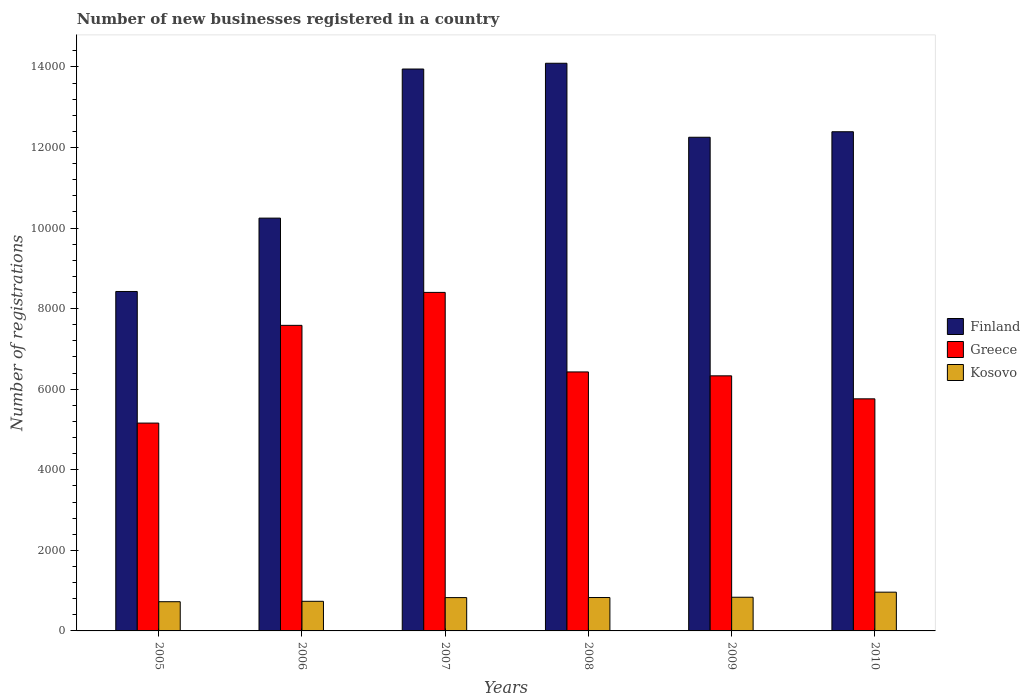How many different coloured bars are there?
Offer a very short reply. 3. How many groups of bars are there?
Ensure brevity in your answer.  6. Are the number of bars per tick equal to the number of legend labels?
Provide a succinct answer. Yes. Are the number of bars on each tick of the X-axis equal?
Offer a very short reply. Yes. How many bars are there on the 5th tick from the right?
Your answer should be very brief. 3. What is the number of new businesses registered in Greece in 2006?
Make the answer very short. 7585. Across all years, what is the maximum number of new businesses registered in Finland?
Your answer should be very brief. 1.41e+04. Across all years, what is the minimum number of new businesses registered in Kosovo?
Offer a terse response. 725. In which year was the number of new businesses registered in Kosovo maximum?
Offer a terse response. 2010. In which year was the number of new businesses registered in Kosovo minimum?
Make the answer very short. 2005. What is the total number of new businesses registered in Greece in the graph?
Make the answer very short. 3.97e+04. What is the difference between the number of new businesses registered in Finland in 2005 and that in 2009?
Your answer should be very brief. -3828. What is the difference between the number of new businesses registered in Greece in 2010 and the number of new businesses registered in Kosovo in 2009?
Provide a succinct answer. 4925. What is the average number of new businesses registered in Kosovo per year?
Make the answer very short. 819. In the year 2006, what is the difference between the number of new businesses registered in Greece and number of new businesses registered in Finland?
Your answer should be compact. -2662. What is the ratio of the number of new businesses registered in Greece in 2005 to that in 2009?
Offer a terse response. 0.81. Is the number of new businesses registered in Kosovo in 2005 less than that in 2009?
Make the answer very short. Yes. Is the difference between the number of new businesses registered in Greece in 2006 and 2010 greater than the difference between the number of new businesses registered in Finland in 2006 and 2010?
Offer a very short reply. Yes. What is the difference between the highest and the second highest number of new businesses registered in Finland?
Offer a very short reply. 143. What is the difference between the highest and the lowest number of new businesses registered in Kosovo?
Keep it short and to the point. 237. Is the sum of the number of new businesses registered in Finland in 2006 and 2008 greater than the maximum number of new businesses registered in Greece across all years?
Give a very brief answer. Yes. What does the 2nd bar from the left in 2006 represents?
Make the answer very short. Greece. How many bars are there?
Your response must be concise. 18. Are the values on the major ticks of Y-axis written in scientific E-notation?
Keep it short and to the point. No. Does the graph contain any zero values?
Offer a very short reply. No. Where does the legend appear in the graph?
Ensure brevity in your answer.  Center right. How many legend labels are there?
Offer a terse response. 3. How are the legend labels stacked?
Ensure brevity in your answer.  Vertical. What is the title of the graph?
Offer a very short reply. Number of new businesses registered in a country. What is the label or title of the X-axis?
Your response must be concise. Years. What is the label or title of the Y-axis?
Offer a terse response. Number of registrations. What is the Number of registrations of Finland in 2005?
Offer a terse response. 8426. What is the Number of registrations of Greece in 2005?
Give a very brief answer. 5159. What is the Number of registrations of Kosovo in 2005?
Keep it short and to the point. 725. What is the Number of registrations of Finland in 2006?
Keep it short and to the point. 1.02e+04. What is the Number of registrations of Greece in 2006?
Your answer should be very brief. 7585. What is the Number of registrations of Kosovo in 2006?
Offer a very short reply. 735. What is the Number of registrations in Finland in 2007?
Ensure brevity in your answer.  1.39e+04. What is the Number of registrations of Greece in 2007?
Provide a short and direct response. 8403. What is the Number of registrations in Kosovo in 2007?
Provide a short and direct response. 827. What is the Number of registrations of Finland in 2008?
Make the answer very short. 1.41e+04. What is the Number of registrations in Greece in 2008?
Your response must be concise. 6429. What is the Number of registrations in Kosovo in 2008?
Ensure brevity in your answer.  829. What is the Number of registrations in Finland in 2009?
Offer a terse response. 1.23e+04. What is the Number of registrations of Greece in 2009?
Offer a very short reply. 6332. What is the Number of registrations in Kosovo in 2009?
Make the answer very short. 836. What is the Number of registrations in Finland in 2010?
Make the answer very short. 1.24e+04. What is the Number of registrations of Greece in 2010?
Make the answer very short. 5761. What is the Number of registrations of Kosovo in 2010?
Offer a terse response. 962. Across all years, what is the maximum Number of registrations of Finland?
Offer a terse response. 1.41e+04. Across all years, what is the maximum Number of registrations in Greece?
Offer a very short reply. 8403. Across all years, what is the maximum Number of registrations in Kosovo?
Offer a very short reply. 962. Across all years, what is the minimum Number of registrations of Finland?
Give a very brief answer. 8426. Across all years, what is the minimum Number of registrations in Greece?
Provide a succinct answer. 5159. Across all years, what is the minimum Number of registrations of Kosovo?
Provide a short and direct response. 725. What is the total Number of registrations in Finland in the graph?
Make the answer very short. 7.14e+04. What is the total Number of registrations in Greece in the graph?
Keep it short and to the point. 3.97e+04. What is the total Number of registrations in Kosovo in the graph?
Your answer should be very brief. 4914. What is the difference between the Number of registrations in Finland in 2005 and that in 2006?
Your answer should be very brief. -1821. What is the difference between the Number of registrations in Greece in 2005 and that in 2006?
Your response must be concise. -2426. What is the difference between the Number of registrations of Finland in 2005 and that in 2007?
Keep it short and to the point. -5522. What is the difference between the Number of registrations in Greece in 2005 and that in 2007?
Your response must be concise. -3244. What is the difference between the Number of registrations in Kosovo in 2005 and that in 2007?
Offer a terse response. -102. What is the difference between the Number of registrations in Finland in 2005 and that in 2008?
Ensure brevity in your answer.  -5665. What is the difference between the Number of registrations of Greece in 2005 and that in 2008?
Your answer should be compact. -1270. What is the difference between the Number of registrations of Kosovo in 2005 and that in 2008?
Ensure brevity in your answer.  -104. What is the difference between the Number of registrations in Finland in 2005 and that in 2009?
Keep it short and to the point. -3828. What is the difference between the Number of registrations of Greece in 2005 and that in 2009?
Keep it short and to the point. -1173. What is the difference between the Number of registrations in Kosovo in 2005 and that in 2009?
Ensure brevity in your answer.  -111. What is the difference between the Number of registrations of Finland in 2005 and that in 2010?
Make the answer very short. -3965. What is the difference between the Number of registrations in Greece in 2005 and that in 2010?
Keep it short and to the point. -602. What is the difference between the Number of registrations of Kosovo in 2005 and that in 2010?
Offer a very short reply. -237. What is the difference between the Number of registrations in Finland in 2006 and that in 2007?
Your answer should be very brief. -3701. What is the difference between the Number of registrations in Greece in 2006 and that in 2007?
Provide a succinct answer. -818. What is the difference between the Number of registrations in Kosovo in 2006 and that in 2007?
Provide a short and direct response. -92. What is the difference between the Number of registrations in Finland in 2006 and that in 2008?
Your response must be concise. -3844. What is the difference between the Number of registrations of Greece in 2006 and that in 2008?
Your answer should be compact. 1156. What is the difference between the Number of registrations of Kosovo in 2006 and that in 2008?
Your response must be concise. -94. What is the difference between the Number of registrations of Finland in 2006 and that in 2009?
Offer a very short reply. -2007. What is the difference between the Number of registrations in Greece in 2006 and that in 2009?
Your response must be concise. 1253. What is the difference between the Number of registrations of Kosovo in 2006 and that in 2009?
Provide a short and direct response. -101. What is the difference between the Number of registrations of Finland in 2006 and that in 2010?
Your answer should be compact. -2144. What is the difference between the Number of registrations of Greece in 2006 and that in 2010?
Ensure brevity in your answer.  1824. What is the difference between the Number of registrations in Kosovo in 2006 and that in 2010?
Provide a succinct answer. -227. What is the difference between the Number of registrations of Finland in 2007 and that in 2008?
Ensure brevity in your answer.  -143. What is the difference between the Number of registrations of Greece in 2007 and that in 2008?
Keep it short and to the point. 1974. What is the difference between the Number of registrations in Kosovo in 2007 and that in 2008?
Provide a short and direct response. -2. What is the difference between the Number of registrations in Finland in 2007 and that in 2009?
Provide a short and direct response. 1694. What is the difference between the Number of registrations of Greece in 2007 and that in 2009?
Your answer should be very brief. 2071. What is the difference between the Number of registrations in Finland in 2007 and that in 2010?
Your answer should be compact. 1557. What is the difference between the Number of registrations of Greece in 2007 and that in 2010?
Provide a short and direct response. 2642. What is the difference between the Number of registrations in Kosovo in 2007 and that in 2010?
Offer a very short reply. -135. What is the difference between the Number of registrations of Finland in 2008 and that in 2009?
Keep it short and to the point. 1837. What is the difference between the Number of registrations of Greece in 2008 and that in 2009?
Ensure brevity in your answer.  97. What is the difference between the Number of registrations in Kosovo in 2008 and that in 2009?
Keep it short and to the point. -7. What is the difference between the Number of registrations in Finland in 2008 and that in 2010?
Offer a terse response. 1700. What is the difference between the Number of registrations of Greece in 2008 and that in 2010?
Give a very brief answer. 668. What is the difference between the Number of registrations in Kosovo in 2008 and that in 2010?
Offer a terse response. -133. What is the difference between the Number of registrations in Finland in 2009 and that in 2010?
Provide a succinct answer. -137. What is the difference between the Number of registrations of Greece in 2009 and that in 2010?
Offer a very short reply. 571. What is the difference between the Number of registrations in Kosovo in 2009 and that in 2010?
Your response must be concise. -126. What is the difference between the Number of registrations in Finland in 2005 and the Number of registrations in Greece in 2006?
Offer a terse response. 841. What is the difference between the Number of registrations of Finland in 2005 and the Number of registrations of Kosovo in 2006?
Offer a terse response. 7691. What is the difference between the Number of registrations in Greece in 2005 and the Number of registrations in Kosovo in 2006?
Provide a short and direct response. 4424. What is the difference between the Number of registrations of Finland in 2005 and the Number of registrations of Kosovo in 2007?
Offer a terse response. 7599. What is the difference between the Number of registrations of Greece in 2005 and the Number of registrations of Kosovo in 2007?
Give a very brief answer. 4332. What is the difference between the Number of registrations in Finland in 2005 and the Number of registrations in Greece in 2008?
Offer a terse response. 1997. What is the difference between the Number of registrations of Finland in 2005 and the Number of registrations of Kosovo in 2008?
Ensure brevity in your answer.  7597. What is the difference between the Number of registrations of Greece in 2005 and the Number of registrations of Kosovo in 2008?
Your answer should be compact. 4330. What is the difference between the Number of registrations in Finland in 2005 and the Number of registrations in Greece in 2009?
Your response must be concise. 2094. What is the difference between the Number of registrations in Finland in 2005 and the Number of registrations in Kosovo in 2009?
Your response must be concise. 7590. What is the difference between the Number of registrations in Greece in 2005 and the Number of registrations in Kosovo in 2009?
Ensure brevity in your answer.  4323. What is the difference between the Number of registrations of Finland in 2005 and the Number of registrations of Greece in 2010?
Give a very brief answer. 2665. What is the difference between the Number of registrations in Finland in 2005 and the Number of registrations in Kosovo in 2010?
Your answer should be compact. 7464. What is the difference between the Number of registrations in Greece in 2005 and the Number of registrations in Kosovo in 2010?
Your answer should be very brief. 4197. What is the difference between the Number of registrations of Finland in 2006 and the Number of registrations of Greece in 2007?
Give a very brief answer. 1844. What is the difference between the Number of registrations in Finland in 2006 and the Number of registrations in Kosovo in 2007?
Your answer should be very brief. 9420. What is the difference between the Number of registrations in Greece in 2006 and the Number of registrations in Kosovo in 2007?
Your answer should be very brief. 6758. What is the difference between the Number of registrations in Finland in 2006 and the Number of registrations in Greece in 2008?
Offer a very short reply. 3818. What is the difference between the Number of registrations of Finland in 2006 and the Number of registrations of Kosovo in 2008?
Keep it short and to the point. 9418. What is the difference between the Number of registrations in Greece in 2006 and the Number of registrations in Kosovo in 2008?
Give a very brief answer. 6756. What is the difference between the Number of registrations of Finland in 2006 and the Number of registrations of Greece in 2009?
Provide a succinct answer. 3915. What is the difference between the Number of registrations of Finland in 2006 and the Number of registrations of Kosovo in 2009?
Provide a short and direct response. 9411. What is the difference between the Number of registrations of Greece in 2006 and the Number of registrations of Kosovo in 2009?
Provide a succinct answer. 6749. What is the difference between the Number of registrations in Finland in 2006 and the Number of registrations in Greece in 2010?
Your answer should be compact. 4486. What is the difference between the Number of registrations of Finland in 2006 and the Number of registrations of Kosovo in 2010?
Provide a short and direct response. 9285. What is the difference between the Number of registrations of Greece in 2006 and the Number of registrations of Kosovo in 2010?
Your answer should be compact. 6623. What is the difference between the Number of registrations of Finland in 2007 and the Number of registrations of Greece in 2008?
Your response must be concise. 7519. What is the difference between the Number of registrations of Finland in 2007 and the Number of registrations of Kosovo in 2008?
Provide a short and direct response. 1.31e+04. What is the difference between the Number of registrations of Greece in 2007 and the Number of registrations of Kosovo in 2008?
Offer a terse response. 7574. What is the difference between the Number of registrations of Finland in 2007 and the Number of registrations of Greece in 2009?
Keep it short and to the point. 7616. What is the difference between the Number of registrations of Finland in 2007 and the Number of registrations of Kosovo in 2009?
Ensure brevity in your answer.  1.31e+04. What is the difference between the Number of registrations of Greece in 2007 and the Number of registrations of Kosovo in 2009?
Provide a short and direct response. 7567. What is the difference between the Number of registrations of Finland in 2007 and the Number of registrations of Greece in 2010?
Your response must be concise. 8187. What is the difference between the Number of registrations in Finland in 2007 and the Number of registrations in Kosovo in 2010?
Ensure brevity in your answer.  1.30e+04. What is the difference between the Number of registrations in Greece in 2007 and the Number of registrations in Kosovo in 2010?
Give a very brief answer. 7441. What is the difference between the Number of registrations in Finland in 2008 and the Number of registrations in Greece in 2009?
Give a very brief answer. 7759. What is the difference between the Number of registrations in Finland in 2008 and the Number of registrations in Kosovo in 2009?
Make the answer very short. 1.33e+04. What is the difference between the Number of registrations of Greece in 2008 and the Number of registrations of Kosovo in 2009?
Provide a succinct answer. 5593. What is the difference between the Number of registrations of Finland in 2008 and the Number of registrations of Greece in 2010?
Provide a succinct answer. 8330. What is the difference between the Number of registrations in Finland in 2008 and the Number of registrations in Kosovo in 2010?
Your response must be concise. 1.31e+04. What is the difference between the Number of registrations of Greece in 2008 and the Number of registrations of Kosovo in 2010?
Keep it short and to the point. 5467. What is the difference between the Number of registrations in Finland in 2009 and the Number of registrations in Greece in 2010?
Give a very brief answer. 6493. What is the difference between the Number of registrations of Finland in 2009 and the Number of registrations of Kosovo in 2010?
Make the answer very short. 1.13e+04. What is the difference between the Number of registrations of Greece in 2009 and the Number of registrations of Kosovo in 2010?
Provide a short and direct response. 5370. What is the average Number of registrations of Finland per year?
Your response must be concise. 1.19e+04. What is the average Number of registrations of Greece per year?
Ensure brevity in your answer.  6611.5. What is the average Number of registrations of Kosovo per year?
Your answer should be very brief. 819. In the year 2005, what is the difference between the Number of registrations in Finland and Number of registrations in Greece?
Make the answer very short. 3267. In the year 2005, what is the difference between the Number of registrations of Finland and Number of registrations of Kosovo?
Your answer should be compact. 7701. In the year 2005, what is the difference between the Number of registrations of Greece and Number of registrations of Kosovo?
Give a very brief answer. 4434. In the year 2006, what is the difference between the Number of registrations of Finland and Number of registrations of Greece?
Offer a terse response. 2662. In the year 2006, what is the difference between the Number of registrations of Finland and Number of registrations of Kosovo?
Keep it short and to the point. 9512. In the year 2006, what is the difference between the Number of registrations of Greece and Number of registrations of Kosovo?
Ensure brevity in your answer.  6850. In the year 2007, what is the difference between the Number of registrations of Finland and Number of registrations of Greece?
Your answer should be very brief. 5545. In the year 2007, what is the difference between the Number of registrations of Finland and Number of registrations of Kosovo?
Your answer should be very brief. 1.31e+04. In the year 2007, what is the difference between the Number of registrations in Greece and Number of registrations in Kosovo?
Your answer should be very brief. 7576. In the year 2008, what is the difference between the Number of registrations in Finland and Number of registrations in Greece?
Offer a very short reply. 7662. In the year 2008, what is the difference between the Number of registrations of Finland and Number of registrations of Kosovo?
Make the answer very short. 1.33e+04. In the year 2008, what is the difference between the Number of registrations of Greece and Number of registrations of Kosovo?
Your answer should be very brief. 5600. In the year 2009, what is the difference between the Number of registrations in Finland and Number of registrations in Greece?
Offer a very short reply. 5922. In the year 2009, what is the difference between the Number of registrations of Finland and Number of registrations of Kosovo?
Provide a short and direct response. 1.14e+04. In the year 2009, what is the difference between the Number of registrations of Greece and Number of registrations of Kosovo?
Keep it short and to the point. 5496. In the year 2010, what is the difference between the Number of registrations of Finland and Number of registrations of Greece?
Ensure brevity in your answer.  6630. In the year 2010, what is the difference between the Number of registrations in Finland and Number of registrations in Kosovo?
Your answer should be very brief. 1.14e+04. In the year 2010, what is the difference between the Number of registrations in Greece and Number of registrations in Kosovo?
Your answer should be very brief. 4799. What is the ratio of the Number of registrations in Finland in 2005 to that in 2006?
Keep it short and to the point. 0.82. What is the ratio of the Number of registrations of Greece in 2005 to that in 2006?
Make the answer very short. 0.68. What is the ratio of the Number of registrations in Kosovo in 2005 to that in 2006?
Ensure brevity in your answer.  0.99. What is the ratio of the Number of registrations in Finland in 2005 to that in 2007?
Make the answer very short. 0.6. What is the ratio of the Number of registrations in Greece in 2005 to that in 2007?
Give a very brief answer. 0.61. What is the ratio of the Number of registrations of Kosovo in 2005 to that in 2007?
Offer a very short reply. 0.88. What is the ratio of the Number of registrations of Finland in 2005 to that in 2008?
Provide a short and direct response. 0.6. What is the ratio of the Number of registrations of Greece in 2005 to that in 2008?
Give a very brief answer. 0.8. What is the ratio of the Number of registrations of Kosovo in 2005 to that in 2008?
Your response must be concise. 0.87. What is the ratio of the Number of registrations of Finland in 2005 to that in 2009?
Ensure brevity in your answer.  0.69. What is the ratio of the Number of registrations in Greece in 2005 to that in 2009?
Your answer should be compact. 0.81. What is the ratio of the Number of registrations of Kosovo in 2005 to that in 2009?
Provide a short and direct response. 0.87. What is the ratio of the Number of registrations in Finland in 2005 to that in 2010?
Keep it short and to the point. 0.68. What is the ratio of the Number of registrations in Greece in 2005 to that in 2010?
Give a very brief answer. 0.9. What is the ratio of the Number of registrations in Kosovo in 2005 to that in 2010?
Ensure brevity in your answer.  0.75. What is the ratio of the Number of registrations in Finland in 2006 to that in 2007?
Offer a terse response. 0.73. What is the ratio of the Number of registrations of Greece in 2006 to that in 2007?
Provide a succinct answer. 0.9. What is the ratio of the Number of registrations in Kosovo in 2006 to that in 2007?
Provide a succinct answer. 0.89. What is the ratio of the Number of registrations of Finland in 2006 to that in 2008?
Ensure brevity in your answer.  0.73. What is the ratio of the Number of registrations in Greece in 2006 to that in 2008?
Your answer should be compact. 1.18. What is the ratio of the Number of registrations of Kosovo in 2006 to that in 2008?
Ensure brevity in your answer.  0.89. What is the ratio of the Number of registrations of Finland in 2006 to that in 2009?
Your answer should be very brief. 0.84. What is the ratio of the Number of registrations of Greece in 2006 to that in 2009?
Make the answer very short. 1.2. What is the ratio of the Number of registrations of Kosovo in 2006 to that in 2009?
Keep it short and to the point. 0.88. What is the ratio of the Number of registrations of Finland in 2006 to that in 2010?
Your response must be concise. 0.83. What is the ratio of the Number of registrations in Greece in 2006 to that in 2010?
Provide a succinct answer. 1.32. What is the ratio of the Number of registrations in Kosovo in 2006 to that in 2010?
Provide a short and direct response. 0.76. What is the ratio of the Number of registrations in Greece in 2007 to that in 2008?
Your answer should be compact. 1.31. What is the ratio of the Number of registrations in Kosovo in 2007 to that in 2008?
Offer a very short reply. 1. What is the ratio of the Number of registrations of Finland in 2007 to that in 2009?
Keep it short and to the point. 1.14. What is the ratio of the Number of registrations in Greece in 2007 to that in 2009?
Keep it short and to the point. 1.33. What is the ratio of the Number of registrations of Kosovo in 2007 to that in 2009?
Provide a short and direct response. 0.99. What is the ratio of the Number of registrations in Finland in 2007 to that in 2010?
Give a very brief answer. 1.13. What is the ratio of the Number of registrations in Greece in 2007 to that in 2010?
Ensure brevity in your answer.  1.46. What is the ratio of the Number of registrations in Kosovo in 2007 to that in 2010?
Keep it short and to the point. 0.86. What is the ratio of the Number of registrations in Finland in 2008 to that in 2009?
Ensure brevity in your answer.  1.15. What is the ratio of the Number of registrations of Greece in 2008 to that in 2009?
Provide a short and direct response. 1.02. What is the ratio of the Number of registrations of Finland in 2008 to that in 2010?
Provide a succinct answer. 1.14. What is the ratio of the Number of registrations in Greece in 2008 to that in 2010?
Provide a succinct answer. 1.12. What is the ratio of the Number of registrations in Kosovo in 2008 to that in 2010?
Your response must be concise. 0.86. What is the ratio of the Number of registrations in Finland in 2009 to that in 2010?
Give a very brief answer. 0.99. What is the ratio of the Number of registrations in Greece in 2009 to that in 2010?
Provide a succinct answer. 1.1. What is the ratio of the Number of registrations in Kosovo in 2009 to that in 2010?
Provide a short and direct response. 0.87. What is the difference between the highest and the second highest Number of registrations in Finland?
Make the answer very short. 143. What is the difference between the highest and the second highest Number of registrations in Greece?
Your answer should be compact. 818. What is the difference between the highest and the second highest Number of registrations in Kosovo?
Make the answer very short. 126. What is the difference between the highest and the lowest Number of registrations of Finland?
Ensure brevity in your answer.  5665. What is the difference between the highest and the lowest Number of registrations of Greece?
Give a very brief answer. 3244. What is the difference between the highest and the lowest Number of registrations in Kosovo?
Make the answer very short. 237. 